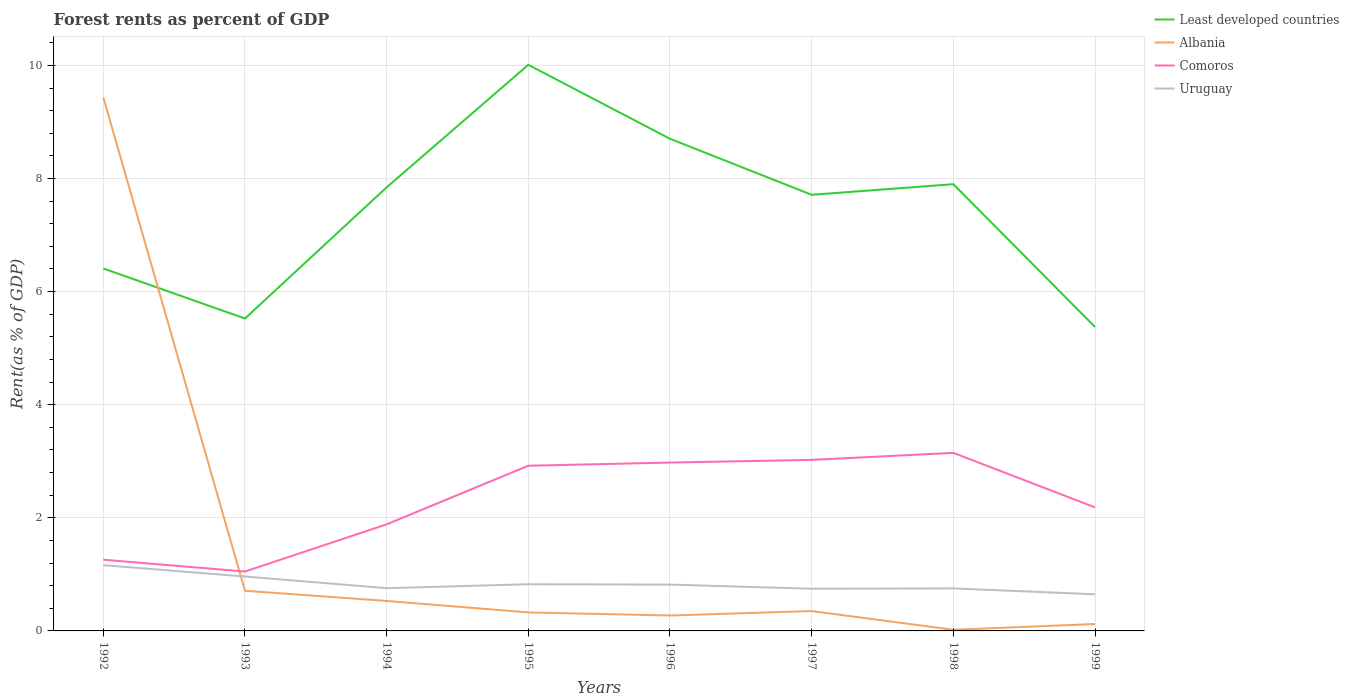How many different coloured lines are there?
Your answer should be compact. 4. Across all years, what is the maximum forest rent in Albania?
Your answer should be compact. 0.02. What is the total forest rent in Comoros in the graph?
Provide a succinct answer. -1.72. What is the difference between the highest and the second highest forest rent in Albania?
Provide a short and direct response. 9.42. How many lines are there?
Offer a terse response. 4. What is the difference between two consecutive major ticks on the Y-axis?
Your answer should be very brief. 2. How are the legend labels stacked?
Give a very brief answer. Vertical. What is the title of the graph?
Your response must be concise. Forest rents as percent of GDP. Does "West Bank and Gaza" appear as one of the legend labels in the graph?
Your response must be concise. No. What is the label or title of the Y-axis?
Make the answer very short. Rent(as % of GDP). What is the Rent(as % of GDP) in Least developed countries in 1992?
Your answer should be very brief. 6.41. What is the Rent(as % of GDP) in Albania in 1992?
Your answer should be compact. 9.44. What is the Rent(as % of GDP) in Comoros in 1992?
Keep it short and to the point. 1.26. What is the Rent(as % of GDP) in Uruguay in 1992?
Provide a short and direct response. 1.16. What is the Rent(as % of GDP) in Least developed countries in 1993?
Offer a terse response. 5.52. What is the Rent(as % of GDP) of Albania in 1993?
Ensure brevity in your answer.  0.71. What is the Rent(as % of GDP) in Comoros in 1993?
Keep it short and to the point. 1.05. What is the Rent(as % of GDP) of Uruguay in 1993?
Keep it short and to the point. 0.96. What is the Rent(as % of GDP) of Least developed countries in 1994?
Provide a succinct answer. 7.84. What is the Rent(as % of GDP) of Albania in 1994?
Keep it short and to the point. 0.53. What is the Rent(as % of GDP) of Comoros in 1994?
Offer a terse response. 1.88. What is the Rent(as % of GDP) of Uruguay in 1994?
Ensure brevity in your answer.  0.76. What is the Rent(as % of GDP) in Least developed countries in 1995?
Keep it short and to the point. 10.01. What is the Rent(as % of GDP) in Albania in 1995?
Give a very brief answer. 0.33. What is the Rent(as % of GDP) of Comoros in 1995?
Your answer should be very brief. 2.92. What is the Rent(as % of GDP) in Uruguay in 1995?
Provide a short and direct response. 0.83. What is the Rent(as % of GDP) of Least developed countries in 1996?
Offer a very short reply. 8.7. What is the Rent(as % of GDP) of Albania in 1996?
Your response must be concise. 0.27. What is the Rent(as % of GDP) of Comoros in 1996?
Your answer should be compact. 2.98. What is the Rent(as % of GDP) in Uruguay in 1996?
Offer a terse response. 0.82. What is the Rent(as % of GDP) of Least developed countries in 1997?
Your response must be concise. 7.71. What is the Rent(as % of GDP) in Albania in 1997?
Your answer should be compact. 0.35. What is the Rent(as % of GDP) in Comoros in 1997?
Ensure brevity in your answer.  3.02. What is the Rent(as % of GDP) in Uruguay in 1997?
Give a very brief answer. 0.75. What is the Rent(as % of GDP) of Least developed countries in 1998?
Offer a terse response. 7.9. What is the Rent(as % of GDP) of Albania in 1998?
Provide a short and direct response. 0.02. What is the Rent(as % of GDP) in Comoros in 1998?
Your answer should be very brief. 3.15. What is the Rent(as % of GDP) in Uruguay in 1998?
Your response must be concise. 0.75. What is the Rent(as % of GDP) of Least developed countries in 1999?
Your response must be concise. 5.38. What is the Rent(as % of GDP) in Albania in 1999?
Your answer should be compact. 0.12. What is the Rent(as % of GDP) in Comoros in 1999?
Offer a terse response. 2.18. What is the Rent(as % of GDP) in Uruguay in 1999?
Ensure brevity in your answer.  0.65. Across all years, what is the maximum Rent(as % of GDP) of Least developed countries?
Give a very brief answer. 10.01. Across all years, what is the maximum Rent(as % of GDP) in Albania?
Give a very brief answer. 9.44. Across all years, what is the maximum Rent(as % of GDP) in Comoros?
Your response must be concise. 3.15. Across all years, what is the maximum Rent(as % of GDP) in Uruguay?
Offer a very short reply. 1.16. Across all years, what is the minimum Rent(as % of GDP) of Least developed countries?
Your answer should be very brief. 5.38. Across all years, what is the minimum Rent(as % of GDP) of Albania?
Give a very brief answer. 0.02. Across all years, what is the minimum Rent(as % of GDP) in Comoros?
Your answer should be compact. 1.05. Across all years, what is the minimum Rent(as % of GDP) in Uruguay?
Provide a succinct answer. 0.65. What is the total Rent(as % of GDP) of Least developed countries in the graph?
Ensure brevity in your answer.  59.48. What is the total Rent(as % of GDP) in Albania in the graph?
Give a very brief answer. 11.77. What is the total Rent(as % of GDP) of Comoros in the graph?
Give a very brief answer. 18.45. What is the total Rent(as % of GDP) in Uruguay in the graph?
Your answer should be compact. 6.67. What is the difference between the Rent(as % of GDP) of Least developed countries in 1992 and that in 1993?
Ensure brevity in your answer.  0.89. What is the difference between the Rent(as % of GDP) in Albania in 1992 and that in 1993?
Provide a short and direct response. 8.73. What is the difference between the Rent(as % of GDP) of Comoros in 1992 and that in 1993?
Offer a very short reply. 0.21. What is the difference between the Rent(as % of GDP) of Uruguay in 1992 and that in 1993?
Offer a very short reply. 0.2. What is the difference between the Rent(as % of GDP) in Least developed countries in 1992 and that in 1994?
Your answer should be very brief. -1.43. What is the difference between the Rent(as % of GDP) of Albania in 1992 and that in 1994?
Offer a terse response. 8.91. What is the difference between the Rent(as % of GDP) in Comoros in 1992 and that in 1994?
Your answer should be compact. -0.62. What is the difference between the Rent(as % of GDP) of Uruguay in 1992 and that in 1994?
Ensure brevity in your answer.  0.41. What is the difference between the Rent(as % of GDP) of Least developed countries in 1992 and that in 1995?
Offer a terse response. -3.6. What is the difference between the Rent(as % of GDP) of Albania in 1992 and that in 1995?
Give a very brief answer. 9.11. What is the difference between the Rent(as % of GDP) of Comoros in 1992 and that in 1995?
Give a very brief answer. -1.66. What is the difference between the Rent(as % of GDP) of Uruguay in 1992 and that in 1995?
Provide a short and direct response. 0.34. What is the difference between the Rent(as % of GDP) in Least developed countries in 1992 and that in 1996?
Keep it short and to the point. -2.29. What is the difference between the Rent(as % of GDP) of Albania in 1992 and that in 1996?
Provide a short and direct response. 9.16. What is the difference between the Rent(as % of GDP) in Comoros in 1992 and that in 1996?
Offer a very short reply. -1.72. What is the difference between the Rent(as % of GDP) in Uruguay in 1992 and that in 1996?
Ensure brevity in your answer.  0.34. What is the difference between the Rent(as % of GDP) of Least developed countries in 1992 and that in 1997?
Provide a succinct answer. -1.3. What is the difference between the Rent(as % of GDP) in Albania in 1992 and that in 1997?
Make the answer very short. 9.09. What is the difference between the Rent(as % of GDP) of Comoros in 1992 and that in 1997?
Provide a succinct answer. -1.76. What is the difference between the Rent(as % of GDP) in Uruguay in 1992 and that in 1997?
Ensure brevity in your answer.  0.42. What is the difference between the Rent(as % of GDP) of Least developed countries in 1992 and that in 1998?
Your answer should be compact. -1.49. What is the difference between the Rent(as % of GDP) in Albania in 1992 and that in 1998?
Your response must be concise. 9.42. What is the difference between the Rent(as % of GDP) of Comoros in 1992 and that in 1998?
Your answer should be very brief. -1.89. What is the difference between the Rent(as % of GDP) in Uruguay in 1992 and that in 1998?
Ensure brevity in your answer.  0.41. What is the difference between the Rent(as % of GDP) of Least developed countries in 1992 and that in 1999?
Keep it short and to the point. 1.03. What is the difference between the Rent(as % of GDP) in Albania in 1992 and that in 1999?
Your answer should be compact. 9.31. What is the difference between the Rent(as % of GDP) of Comoros in 1992 and that in 1999?
Keep it short and to the point. -0.93. What is the difference between the Rent(as % of GDP) of Uruguay in 1992 and that in 1999?
Ensure brevity in your answer.  0.51. What is the difference between the Rent(as % of GDP) in Least developed countries in 1993 and that in 1994?
Provide a succinct answer. -2.32. What is the difference between the Rent(as % of GDP) of Albania in 1993 and that in 1994?
Provide a succinct answer. 0.18. What is the difference between the Rent(as % of GDP) of Comoros in 1993 and that in 1994?
Your answer should be very brief. -0.83. What is the difference between the Rent(as % of GDP) in Uruguay in 1993 and that in 1994?
Offer a very short reply. 0.21. What is the difference between the Rent(as % of GDP) in Least developed countries in 1993 and that in 1995?
Provide a short and direct response. -4.49. What is the difference between the Rent(as % of GDP) in Albania in 1993 and that in 1995?
Provide a succinct answer. 0.38. What is the difference between the Rent(as % of GDP) of Comoros in 1993 and that in 1995?
Your response must be concise. -1.87. What is the difference between the Rent(as % of GDP) in Uruguay in 1993 and that in 1995?
Provide a succinct answer. 0.14. What is the difference between the Rent(as % of GDP) of Least developed countries in 1993 and that in 1996?
Give a very brief answer. -3.18. What is the difference between the Rent(as % of GDP) in Albania in 1993 and that in 1996?
Offer a very short reply. 0.44. What is the difference between the Rent(as % of GDP) of Comoros in 1993 and that in 1996?
Ensure brevity in your answer.  -1.93. What is the difference between the Rent(as % of GDP) of Uruguay in 1993 and that in 1996?
Your answer should be compact. 0.14. What is the difference between the Rent(as % of GDP) of Least developed countries in 1993 and that in 1997?
Your answer should be very brief. -2.19. What is the difference between the Rent(as % of GDP) in Albania in 1993 and that in 1997?
Keep it short and to the point. 0.36. What is the difference between the Rent(as % of GDP) of Comoros in 1993 and that in 1997?
Provide a short and direct response. -1.97. What is the difference between the Rent(as % of GDP) in Uruguay in 1993 and that in 1997?
Keep it short and to the point. 0.22. What is the difference between the Rent(as % of GDP) in Least developed countries in 1993 and that in 1998?
Keep it short and to the point. -2.38. What is the difference between the Rent(as % of GDP) in Albania in 1993 and that in 1998?
Your response must be concise. 0.69. What is the difference between the Rent(as % of GDP) of Comoros in 1993 and that in 1998?
Offer a terse response. -2.1. What is the difference between the Rent(as % of GDP) in Uruguay in 1993 and that in 1998?
Make the answer very short. 0.21. What is the difference between the Rent(as % of GDP) in Least developed countries in 1993 and that in 1999?
Provide a short and direct response. 0.15. What is the difference between the Rent(as % of GDP) of Albania in 1993 and that in 1999?
Provide a succinct answer. 0.59. What is the difference between the Rent(as % of GDP) in Comoros in 1993 and that in 1999?
Ensure brevity in your answer.  -1.13. What is the difference between the Rent(as % of GDP) in Uruguay in 1993 and that in 1999?
Your answer should be very brief. 0.31. What is the difference between the Rent(as % of GDP) in Least developed countries in 1994 and that in 1995?
Offer a very short reply. -2.17. What is the difference between the Rent(as % of GDP) in Albania in 1994 and that in 1995?
Your answer should be very brief. 0.2. What is the difference between the Rent(as % of GDP) in Comoros in 1994 and that in 1995?
Your response must be concise. -1.04. What is the difference between the Rent(as % of GDP) in Uruguay in 1994 and that in 1995?
Keep it short and to the point. -0.07. What is the difference between the Rent(as % of GDP) of Least developed countries in 1994 and that in 1996?
Your answer should be very brief. -0.86. What is the difference between the Rent(as % of GDP) of Albania in 1994 and that in 1996?
Your answer should be very brief. 0.26. What is the difference between the Rent(as % of GDP) of Comoros in 1994 and that in 1996?
Keep it short and to the point. -1.09. What is the difference between the Rent(as % of GDP) in Uruguay in 1994 and that in 1996?
Provide a short and direct response. -0.06. What is the difference between the Rent(as % of GDP) in Least developed countries in 1994 and that in 1997?
Provide a short and direct response. 0.13. What is the difference between the Rent(as % of GDP) of Albania in 1994 and that in 1997?
Your response must be concise. 0.18. What is the difference between the Rent(as % of GDP) in Comoros in 1994 and that in 1997?
Offer a very short reply. -1.14. What is the difference between the Rent(as % of GDP) in Uruguay in 1994 and that in 1997?
Your response must be concise. 0.01. What is the difference between the Rent(as % of GDP) of Least developed countries in 1994 and that in 1998?
Offer a terse response. -0.06. What is the difference between the Rent(as % of GDP) of Albania in 1994 and that in 1998?
Your answer should be very brief. 0.51. What is the difference between the Rent(as % of GDP) of Comoros in 1994 and that in 1998?
Your response must be concise. -1.26. What is the difference between the Rent(as % of GDP) of Uruguay in 1994 and that in 1998?
Give a very brief answer. 0. What is the difference between the Rent(as % of GDP) of Least developed countries in 1994 and that in 1999?
Your answer should be very brief. 2.47. What is the difference between the Rent(as % of GDP) in Albania in 1994 and that in 1999?
Offer a very short reply. 0.41. What is the difference between the Rent(as % of GDP) in Comoros in 1994 and that in 1999?
Your answer should be compact. -0.3. What is the difference between the Rent(as % of GDP) of Uruguay in 1994 and that in 1999?
Keep it short and to the point. 0.11. What is the difference between the Rent(as % of GDP) of Least developed countries in 1995 and that in 1996?
Offer a very short reply. 1.31. What is the difference between the Rent(as % of GDP) of Albania in 1995 and that in 1996?
Make the answer very short. 0.05. What is the difference between the Rent(as % of GDP) in Comoros in 1995 and that in 1996?
Your response must be concise. -0.06. What is the difference between the Rent(as % of GDP) of Uruguay in 1995 and that in 1996?
Make the answer very short. 0.01. What is the difference between the Rent(as % of GDP) in Least developed countries in 1995 and that in 1997?
Give a very brief answer. 2.3. What is the difference between the Rent(as % of GDP) in Albania in 1995 and that in 1997?
Your response must be concise. -0.02. What is the difference between the Rent(as % of GDP) in Comoros in 1995 and that in 1997?
Offer a terse response. -0.1. What is the difference between the Rent(as % of GDP) of Uruguay in 1995 and that in 1997?
Ensure brevity in your answer.  0.08. What is the difference between the Rent(as % of GDP) in Least developed countries in 1995 and that in 1998?
Offer a terse response. 2.11. What is the difference between the Rent(as % of GDP) in Albania in 1995 and that in 1998?
Your answer should be very brief. 0.31. What is the difference between the Rent(as % of GDP) of Comoros in 1995 and that in 1998?
Ensure brevity in your answer.  -0.23. What is the difference between the Rent(as % of GDP) of Uruguay in 1995 and that in 1998?
Provide a succinct answer. 0.07. What is the difference between the Rent(as % of GDP) in Least developed countries in 1995 and that in 1999?
Give a very brief answer. 4.63. What is the difference between the Rent(as % of GDP) in Albania in 1995 and that in 1999?
Keep it short and to the point. 0.2. What is the difference between the Rent(as % of GDP) in Comoros in 1995 and that in 1999?
Your response must be concise. 0.74. What is the difference between the Rent(as % of GDP) of Uruguay in 1995 and that in 1999?
Provide a short and direct response. 0.18. What is the difference between the Rent(as % of GDP) in Least developed countries in 1996 and that in 1997?
Your response must be concise. 0.99. What is the difference between the Rent(as % of GDP) of Albania in 1996 and that in 1997?
Provide a succinct answer. -0.08. What is the difference between the Rent(as % of GDP) of Comoros in 1996 and that in 1997?
Make the answer very short. -0.05. What is the difference between the Rent(as % of GDP) of Uruguay in 1996 and that in 1997?
Provide a short and direct response. 0.07. What is the difference between the Rent(as % of GDP) in Least developed countries in 1996 and that in 1998?
Provide a short and direct response. 0.8. What is the difference between the Rent(as % of GDP) in Albania in 1996 and that in 1998?
Ensure brevity in your answer.  0.25. What is the difference between the Rent(as % of GDP) in Comoros in 1996 and that in 1998?
Your answer should be compact. -0.17. What is the difference between the Rent(as % of GDP) of Uruguay in 1996 and that in 1998?
Ensure brevity in your answer.  0.07. What is the difference between the Rent(as % of GDP) in Least developed countries in 1996 and that in 1999?
Provide a short and direct response. 3.33. What is the difference between the Rent(as % of GDP) of Albania in 1996 and that in 1999?
Offer a terse response. 0.15. What is the difference between the Rent(as % of GDP) in Comoros in 1996 and that in 1999?
Give a very brief answer. 0.79. What is the difference between the Rent(as % of GDP) of Uruguay in 1996 and that in 1999?
Your answer should be very brief. 0.17. What is the difference between the Rent(as % of GDP) in Least developed countries in 1997 and that in 1998?
Keep it short and to the point. -0.19. What is the difference between the Rent(as % of GDP) in Albania in 1997 and that in 1998?
Make the answer very short. 0.33. What is the difference between the Rent(as % of GDP) in Comoros in 1997 and that in 1998?
Make the answer very short. -0.12. What is the difference between the Rent(as % of GDP) of Uruguay in 1997 and that in 1998?
Ensure brevity in your answer.  -0.01. What is the difference between the Rent(as % of GDP) of Least developed countries in 1997 and that in 1999?
Offer a very short reply. 2.34. What is the difference between the Rent(as % of GDP) in Albania in 1997 and that in 1999?
Keep it short and to the point. 0.23. What is the difference between the Rent(as % of GDP) of Comoros in 1997 and that in 1999?
Offer a terse response. 0.84. What is the difference between the Rent(as % of GDP) of Uruguay in 1997 and that in 1999?
Make the answer very short. 0.1. What is the difference between the Rent(as % of GDP) in Least developed countries in 1998 and that in 1999?
Your answer should be very brief. 2.52. What is the difference between the Rent(as % of GDP) in Albania in 1998 and that in 1999?
Offer a very short reply. -0.1. What is the difference between the Rent(as % of GDP) of Comoros in 1998 and that in 1999?
Make the answer very short. 0.96. What is the difference between the Rent(as % of GDP) of Uruguay in 1998 and that in 1999?
Make the answer very short. 0.1. What is the difference between the Rent(as % of GDP) in Least developed countries in 1992 and the Rent(as % of GDP) in Albania in 1993?
Ensure brevity in your answer.  5.7. What is the difference between the Rent(as % of GDP) in Least developed countries in 1992 and the Rent(as % of GDP) in Comoros in 1993?
Make the answer very short. 5.36. What is the difference between the Rent(as % of GDP) in Least developed countries in 1992 and the Rent(as % of GDP) in Uruguay in 1993?
Provide a succinct answer. 5.45. What is the difference between the Rent(as % of GDP) in Albania in 1992 and the Rent(as % of GDP) in Comoros in 1993?
Your answer should be very brief. 8.39. What is the difference between the Rent(as % of GDP) of Albania in 1992 and the Rent(as % of GDP) of Uruguay in 1993?
Offer a very short reply. 8.47. What is the difference between the Rent(as % of GDP) in Comoros in 1992 and the Rent(as % of GDP) in Uruguay in 1993?
Your response must be concise. 0.3. What is the difference between the Rent(as % of GDP) in Least developed countries in 1992 and the Rent(as % of GDP) in Albania in 1994?
Give a very brief answer. 5.88. What is the difference between the Rent(as % of GDP) in Least developed countries in 1992 and the Rent(as % of GDP) in Comoros in 1994?
Provide a short and direct response. 4.53. What is the difference between the Rent(as % of GDP) of Least developed countries in 1992 and the Rent(as % of GDP) of Uruguay in 1994?
Ensure brevity in your answer.  5.65. What is the difference between the Rent(as % of GDP) in Albania in 1992 and the Rent(as % of GDP) in Comoros in 1994?
Give a very brief answer. 7.55. What is the difference between the Rent(as % of GDP) in Albania in 1992 and the Rent(as % of GDP) in Uruguay in 1994?
Your answer should be compact. 8.68. What is the difference between the Rent(as % of GDP) in Comoros in 1992 and the Rent(as % of GDP) in Uruguay in 1994?
Ensure brevity in your answer.  0.5. What is the difference between the Rent(as % of GDP) in Least developed countries in 1992 and the Rent(as % of GDP) in Albania in 1995?
Your answer should be compact. 6.08. What is the difference between the Rent(as % of GDP) in Least developed countries in 1992 and the Rent(as % of GDP) in Comoros in 1995?
Give a very brief answer. 3.49. What is the difference between the Rent(as % of GDP) in Least developed countries in 1992 and the Rent(as % of GDP) in Uruguay in 1995?
Keep it short and to the point. 5.58. What is the difference between the Rent(as % of GDP) of Albania in 1992 and the Rent(as % of GDP) of Comoros in 1995?
Offer a very short reply. 6.52. What is the difference between the Rent(as % of GDP) of Albania in 1992 and the Rent(as % of GDP) of Uruguay in 1995?
Give a very brief answer. 8.61. What is the difference between the Rent(as % of GDP) in Comoros in 1992 and the Rent(as % of GDP) in Uruguay in 1995?
Provide a short and direct response. 0.43. What is the difference between the Rent(as % of GDP) of Least developed countries in 1992 and the Rent(as % of GDP) of Albania in 1996?
Provide a succinct answer. 6.14. What is the difference between the Rent(as % of GDP) in Least developed countries in 1992 and the Rent(as % of GDP) in Comoros in 1996?
Give a very brief answer. 3.43. What is the difference between the Rent(as % of GDP) of Least developed countries in 1992 and the Rent(as % of GDP) of Uruguay in 1996?
Your response must be concise. 5.59. What is the difference between the Rent(as % of GDP) of Albania in 1992 and the Rent(as % of GDP) of Comoros in 1996?
Your response must be concise. 6.46. What is the difference between the Rent(as % of GDP) of Albania in 1992 and the Rent(as % of GDP) of Uruguay in 1996?
Your answer should be very brief. 8.62. What is the difference between the Rent(as % of GDP) of Comoros in 1992 and the Rent(as % of GDP) of Uruguay in 1996?
Give a very brief answer. 0.44. What is the difference between the Rent(as % of GDP) of Least developed countries in 1992 and the Rent(as % of GDP) of Albania in 1997?
Provide a succinct answer. 6.06. What is the difference between the Rent(as % of GDP) of Least developed countries in 1992 and the Rent(as % of GDP) of Comoros in 1997?
Keep it short and to the point. 3.39. What is the difference between the Rent(as % of GDP) in Least developed countries in 1992 and the Rent(as % of GDP) in Uruguay in 1997?
Make the answer very short. 5.66. What is the difference between the Rent(as % of GDP) in Albania in 1992 and the Rent(as % of GDP) in Comoros in 1997?
Your answer should be compact. 6.41. What is the difference between the Rent(as % of GDP) in Albania in 1992 and the Rent(as % of GDP) in Uruguay in 1997?
Provide a short and direct response. 8.69. What is the difference between the Rent(as % of GDP) in Comoros in 1992 and the Rent(as % of GDP) in Uruguay in 1997?
Your answer should be compact. 0.51. What is the difference between the Rent(as % of GDP) in Least developed countries in 1992 and the Rent(as % of GDP) in Albania in 1998?
Your response must be concise. 6.39. What is the difference between the Rent(as % of GDP) of Least developed countries in 1992 and the Rent(as % of GDP) of Comoros in 1998?
Make the answer very short. 3.26. What is the difference between the Rent(as % of GDP) in Least developed countries in 1992 and the Rent(as % of GDP) in Uruguay in 1998?
Provide a short and direct response. 5.66. What is the difference between the Rent(as % of GDP) in Albania in 1992 and the Rent(as % of GDP) in Comoros in 1998?
Offer a very short reply. 6.29. What is the difference between the Rent(as % of GDP) of Albania in 1992 and the Rent(as % of GDP) of Uruguay in 1998?
Provide a short and direct response. 8.68. What is the difference between the Rent(as % of GDP) of Comoros in 1992 and the Rent(as % of GDP) of Uruguay in 1998?
Provide a succinct answer. 0.51. What is the difference between the Rent(as % of GDP) in Least developed countries in 1992 and the Rent(as % of GDP) in Albania in 1999?
Keep it short and to the point. 6.29. What is the difference between the Rent(as % of GDP) in Least developed countries in 1992 and the Rent(as % of GDP) in Comoros in 1999?
Ensure brevity in your answer.  4.22. What is the difference between the Rent(as % of GDP) of Least developed countries in 1992 and the Rent(as % of GDP) of Uruguay in 1999?
Offer a terse response. 5.76. What is the difference between the Rent(as % of GDP) of Albania in 1992 and the Rent(as % of GDP) of Comoros in 1999?
Keep it short and to the point. 7.25. What is the difference between the Rent(as % of GDP) of Albania in 1992 and the Rent(as % of GDP) of Uruguay in 1999?
Ensure brevity in your answer.  8.79. What is the difference between the Rent(as % of GDP) in Comoros in 1992 and the Rent(as % of GDP) in Uruguay in 1999?
Ensure brevity in your answer.  0.61. What is the difference between the Rent(as % of GDP) of Least developed countries in 1993 and the Rent(as % of GDP) of Albania in 1994?
Provide a short and direct response. 4.99. What is the difference between the Rent(as % of GDP) in Least developed countries in 1993 and the Rent(as % of GDP) in Comoros in 1994?
Keep it short and to the point. 3.64. What is the difference between the Rent(as % of GDP) of Least developed countries in 1993 and the Rent(as % of GDP) of Uruguay in 1994?
Offer a very short reply. 4.77. What is the difference between the Rent(as % of GDP) of Albania in 1993 and the Rent(as % of GDP) of Comoros in 1994?
Give a very brief answer. -1.17. What is the difference between the Rent(as % of GDP) in Albania in 1993 and the Rent(as % of GDP) in Uruguay in 1994?
Provide a short and direct response. -0.05. What is the difference between the Rent(as % of GDP) of Comoros in 1993 and the Rent(as % of GDP) of Uruguay in 1994?
Offer a very short reply. 0.29. What is the difference between the Rent(as % of GDP) in Least developed countries in 1993 and the Rent(as % of GDP) in Albania in 1995?
Ensure brevity in your answer.  5.2. What is the difference between the Rent(as % of GDP) in Least developed countries in 1993 and the Rent(as % of GDP) in Comoros in 1995?
Provide a succinct answer. 2.6. What is the difference between the Rent(as % of GDP) of Least developed countries in 1993 and the Rent(as % of GDP) of Uruguay in 1995?
Your answer should be compact. 4.7. What is the difference between the Rent(as % of GDP) of Albania in 1993 and the Rent(as % of GDP) of Comoros in 1995?
Provide a succinct answer. -2.21. What is the difference between the Rent(as % of GDP) of Albania in 1993 and the Rent(as % of GDP) of Uruguay in 1995?
Provide a succinct answer. -0.12. What is the difference between the Rent(as % of GDP) of Comoros in 1993 and the Rent(as % of GDP) of Uruguay in 1995?
Provide a short and direct response. 0.23. What is the difference between the Rent(as % of GDP) in Least developed countries in 1993 and the Rent(as % of GDP) in Albania in 1996?
Ensure brevity in your answer.  5.25. What is the difference between the Rent(as % of GDP) in Least developed countries in 1993 and the Rent(as % of GDP) in Comoros in 1996?
Provide a short and direct response. 2.55. What is the difference between the Rent(as % of GDP) in Least developed countries in 1993 and the Rent(as % of GDP) in Uruguay in 1996?
Keep it short and to the point. 4.7. What is the difference between the Rent(as % of GDP) in Albania in 1993 and the Rent(as % of GDP) in Comoros in 1996?
Provide a short and direct response. -2.27. What is the difference between the Rent(as % of GDP) of Albania in 1993 and the Rent(as % of GDP) of Uruguay in 1996?
Ensure brevity in your answer.  -0.11. What is the difference between the Rent(as % of GDP) in Comoros in 1993 and the Rent(as % of GDP) in Uruguay in 1996?
Offer a very short reply. 0.23. What is the difference between the Rent(as % of GDP) of Least developed countries in 1993 and the Rent(as % of GDP) of Albania in 1997?
Ensure brevity in your answer.  5.17. What is the difference between the Rent(as % of GDP) in Least developed countries in 1993 and the Rent(as % of GDP) in Comoros in 1997?
Provide a succinct answer. 2.5. What is the difference between the Rent(as % of GDP) of Least developed countries in 1993 and the Rent(as % of GDP) of Uruguay in 1997?
Your response must be concise. 4.78. What is the difference between the Rent(as % of GDP) of Albania in 1993 and the Rent(as % of GDP) of Comoros in 1997?
Give a very brief answer. -2.31. What is the difference between the Rent(as % of GDP) in Albania in 1993 and the Rent(as % of GDP) in Uruguay in 1997?
Your answer should be very brief. -0.04. What is the difference between the Rent(as % of GDP) of Comoros in 1993 and the Rent(as % of GDP) of Uruguay in 1997?
Provide a succinct answer. 0.3. What is the difference between the Rent(as % of GDP) in Least developed countries in 1993 and the Rent(as % of GDP) in Albania in 1998?
Offer a very short reply. 5.5. What is the difference between the Rent(as % of GDP) in Least developed countries in 1993 and the Rent(as % of GDP) in Comoros in 1998?
Offer a terse response. 2.38. What is the difference between the Rent(as % of GDP) of Least developed countries in 1993 and the Rent(as % of GDP) of Uruguay in 1998?
Provide a short and direct response. 4.77. What is the difference between the Rent(as % of GDP) of Albania in 1993 and the Rent(as % of GDP) of Comoros in 1998?
Your answer should be very brief. -2.44. What is the difference between the Rent(as % of GDP) in Albania in 1993 and the Rent(as % of GDP) in Uruguay in 1998?
Offer a terse response. -0.04. What is the difference between the Rent(as % of GDP) in Comoros in 1993 and the Rent(as % of GDP) in Uruguay in 1998?
Provide a succinct answer. 0.3. What is the difference between the Rent(as % of GDP) of Least developed countries in 1993 and the Rent(as % of GDP) of Albania in 1999?
Your answer should be very brief. 5.4. What is the difference between the Rent(as % of GDP) in Least developed countries in 1993 and the Rent(as % of GDP) in Comoros in 1999?
Keep it short and to the point. 3.34. What is the difference between the Rent(as % of GDP) in Least developed countries in 1993 and the Rent(as % of GDP) in Uruguay in 1999?
Provide a succinct answer. 4.88. What is the difference between the Rent(as % of GDP) in Albania in 1993 and the Rent(as % of GDP) in Comoros in 1999?
Make the answer very short. -1.47. What is the difference between the Rent(as % of GDP) of Albania in 1993 and the Rent(as % of GDP) of Uruguay in 1999?
Provide a succinct answer. 0.06. What is the difference between the Rent(as % of GDP) in Comoros in 1993 and the Rent(as % of GDP) in Uruguay in 1999?
Your answer should be very brief. 0.4. What is the difference between the Rent(as % of GDP) of Least developed countries in 1994 and the Rent(as % of GDP) of Albania in 1995?
Offer a terse response. 7.52. What is the difference between the Rent(as % of GDP) in Least developed countries in 1994 and the Rent(as % of GDP) in Comoros in 1995?
Your response must be concise. 4.92. What is the difference between the Rent(as % of GDP) in Least developed countries in 1994 and the Rent(as % of GDP) in Uruguay in 1995?
Your answer should be very brief. 7.02. What is the difference between the Rent(as % of GDP) of Albania in 1994 and the Rent(as % of GDP) of Comoros in 1995?
Provide a succinct answer. -2.39. What is the difference between the Rent(as % of GDP) of Albania in 1994 and the Rent(as % of GDP) of Uruguay in 1995?
Make the answer very short. -0.3. What is the difference between the Rent(as % of GDP) of Comoros in 1994 and the Rent(as % of GDP) of Uruguay in 1995?
Provide a short and direct response. 1.06. What is the difference between the Rent(as % of GDP) of Least developed countries in 1994 and the Rent(as % of GDP) of Albania in 1996?
Ensure brevity in your answer.  7.57. What is the difference between the Rent(as % of GDP) in Least developed countries in 1994 and the Rent(as % of GDP) in Comoros in 1996?
Your answer should be compact. 4.87. What is the difference between the Rent(as % of GDP) in Least developed countries in 1994 and the Rent(as % of GDP) in Uruguay in 1996?
Provide a short and direct response. 7.02. What is the difference between the Rent(as % of GDP) in Albania in 1994 and the Rent(as % of GDP) in Comoros in 1996?
Provide a succinct answer. -2.45. What is the difference between the Rent(as % of GDP) of Albania in 1994 and the Rent(as % of GDP) of Uruguay in 1996?
Give a very brief answer. -0.29. What is the difference between the Rent(as % of GDP) of Comoros in 1994 and the Rent(as % of GDP) of Uruguay in 1996?
Provide a short and direct response. 1.06. What is the difference between the Rent(as % of GDP) of Least developed countries in 1994 and the Rent(as % of GDP) of Albania in 1997?
Ensure brevity in your answer.  7.49. What is the difference between the Rent(as % of GDP) of Least developed countries in 1994 and the Rent(as % of GDP) of Comoros in 1997?
Make the answer very short. 4.82. What is the difference between the Rent(as % of GDP) of Least developed countries in 1994 and the Rent(as % of GDP) of Uruguay in 1997?
Your answer should be compact. 7.1. What is the difference between the Rent(as % of GDP) of Albania in 1994 and the Rent(as % of GDP) of Comoros in 1997?
Provide a succinct answer. -2.49. What is the difference between the Rent(as % of GDP) in Albania in 1994 and the Rent(as % of GDP) in Uruguay in 1997?
Ensure brevity in your answer.  -0.22. What is the difference between the Rent(as % of GDP) in Comoros in 1994 and the Rent(as % of GDP) in Uruguay in 1997?
Your response must be concise. 1.14. What is the difference between the Rent(as % of GDP) in Least developed countries in 1994 and the Rent(as % of GDP) in Albania in 1998?
Give a very brief answer. 7.82. What is the difference between the Rent(as % of GDP) of Least developed countries in 1994 and the Rent(as % of GDP) of Comoros in 1998?
Your answer should be compact. 4.7. What is the difference between the Rent(as % of GDP) in Least developed countries in 1994 and the Rent(as % of GDP) in Uruguay in 1998?
Your answer should be compact. 7.09. What is the difference between the Rent(as % of GDP) in Albania in 1994 and the Rent(as % of GDP) in Comoros in 1998?
Your answer should be compact. -2.62. What is the difference between the Rent(as % of GDP) of Albania in 1994 and the Rent(as % of GDP) of Uruguay in 1998?
Give a very brief answer. -0.22. What is the difference between the Rent(as % of GDP) of Comoros in 1994 and the Rent(as % of GDP) of Uruguay in 1998?
Provide a succinct answer. 1.13. What is the difference between the Rent(as % of GDP) in Least developed countries in 1994 and the Rent(as % of GDP) in Albania in 1999?
Keep it short and to the point. 7.72. What is the difference between the Rent(as % of GDP) of Least developed countries in 1994 and the Rent(as % of GDP) of Comoros in 1999?
Your answer should be compact. 5.66. What is the difference between the Rent(as % of GDP) in Least developed countries in 1994 and the Rent(as % of GDP) in Uruguay in 1999?
Provide a succinct answer. 7.2. What is the difference between the Rent(as % of GDP) in Albania in 1994 and the Rent(as % of GDP) in Comoros in 1999?
Your answer should be very brief. -1.65. What is the difference between the Rent(as % of GDP) of Albania in 1994 and the Rent(as % of GDP) of Uruguay in 1999?
Make the answer very short. -0.12. What is the difference between the Rent(as % of GDP) in Comoros in 1994 and the Rent(as % of GDP) in Uruguay in 1999?
Give a very brief answer. 1.24. What is the difference between the Rent(as % of GDP) in Least developed countries in 1995 and the Rent(as % of GDP) in Albania in 1996?
Your answer should be very brief. 9.74. What is the difference between the Rent(as % of GDP) in Least developed countries in 1995 and the Rent(as % of GDP) in Comoros in 1996?
Your answer should be very brief. 7.03. What is the difference between the Rent(as % of GDP) in Least developed countries in 1995 and the Rent(as % of GDP) in Uruguay in 1996?
Your answer should be very brief. 9.19. What is the difference between the Rent(as % of GDP) in Albania in 1995 and the Rent(as % of GDP) in Comoros in 1996?
Your response must be concise. -2.65. What is the difference between the Rent(as % of GDP) in Albania in 1995 and the Rent(as % of GDP) in Uruguay in 1996?
Keep it short and to the point. -0.49. What is the difference between the Rent(as % of GDP) in Comoros in 1995 and the Rent(as % of GDP) in Uruguay in 1996?
Give a very brief answer. 2.1. What is the difference between the Rent(as % of GDP) in Least developed countries in 1995 and the Rent(as % of GDP) in Albania in 1997?
Provide a succinct answer. 9.66. What is the difference between the Rent(as % of GDP) of Least developed countries in 1995 and the Rent(as % of GDP) of Comoros in 1997?
Keep it short and to the point. 6.99. What is the difference between the Rent(as % of GDP) in Least developed countries in 1995 and the Rent(as % of GDP) in Uruguay in 1997?
Keep it short and to the point. 9.26. What is the difference between the Rent(as % of GDP) in Albania in 1995 and the Rent(as % of GDP) in Comoros in 1997?
Make the answer very short. -2.7. What is the difference between the Rent(as % of GDP) in Albania in 1995 and the Rent(as % of GDP) in Uruguay in 1997?
Your response must be concise. -0.42. What is the difference between the Rent(as % of GDP) of Comoros in 1995 and the Rent(as % of GDP) of Uruguay in 1997?
Offer a very short reply. 2.18. What is the difference between the Rent(as % of GDP) in Least developed countries in 1995 and the Rent(as % of GDP) in Albania in 1998?
Provide a short and direct response. 9.99. What is the difference between the Rent(as % of GDP) in Least developed countries in 1995 and the Rent(as % of GDP) in Comoros in 1998?
Provide a short and direct response. 6.86. What is the difference between the Rent(as % of GDP) of Least developed countries in 1995 and the Rent(as % of GDP) of Uruguay in 1998?
Your answer should be very brief. 9.26. What is the difference between the Rent(as % of GDP) of Albania in 1995 and the Rent(as % of GDP) of Comoros in 1998?
Offer a terse response. -2.82. What is the difference between the Rent(as % of GDP) in Albania in 1995 and the Rent(as % of GDP) in Uruguay in 1998?
Your answer should be compact. -0.42. What is the difference between the Rent(as % of GDP) in Comoros in 1995 and the Rent(as % of GDP) in Uruguay in 1998?
Offer a terse response. 2.17. What is the difference between the Rent(as % of GDP) in Least developed countries in 1995 and the Rent(as % of GDP) in Albania in 1999?
Your response must be concise. 9.89. What is the difference between the Rent(as % of GDP) of Least developed countries in 1995 and the Rent(as % of GDP) of Comoros in 1999?
Make the answer very short. 7.83. What is the difference between the Rent(as % of GDP) of Least developed countries in 1995 and the Rent(as % of GDP) of Uruguay in 1999?
Keep it short and to the point. 9.36. What is the difference between the Rent(as % of GDP) of Albania in 1995 and the Rent(as % of GDP) of Comoros in 1999?
Provide a short and direct response. -1.86. What is the difference between the Rent(as % of GDP) of Albania in 1995 and the Rent(as % of GDP) of Uruguay in 1999?
Offer a very short reply. -0.32. What is the difference between the Rent(as % of GDP) of Comoros in 1995 and the Rent(as % of GDP) of Uruguay in 1999?
Make the answer very short. 2.27. What is the difference between the Rent(as % of GDP) in Least developed countries in 1996 and the Rent(as % of GDP) in Albania in 1997?
Your response must be concise. 8.35. What is the difference between the Rent(as % of GDP) in Least developed countries in 1996 and the Rent(as % of GDP) in Comoros in 1997?
Give a very brief answer. 5.68. What is the difference between the Rent(as % of GDP) in Least developed countries in 1996 and the Rent(as % of GDP) in Uruguay in 1997?
Ensure brevity in your answer.  7.96. What is the difference between the Rent(as % of GDP) of Albania in 1996 and the Rent(as % of GDP) of Comoros in 1997?
Ensure brevity in your answer.  -2.75. What is the difference between the Rent(as % of GDP) in Albania in 1996 and the Rent(as % of GDP) in Uruguay in 1997?
Provide a short and direct response. -0.47. What is the difference between the Rent(as % of GDP) in Comoros in 1996 and the Rent(as % of GDP) in Uruguay in 1997?
Your response must be concise. 2.23. What is the difference between the Rent(as % of GDP) of Least developed countries in 1996 and the Rent(as % of GDP) of Albania in 1998?
Provide a short and direct response. 8.68. What is the difference between the Rent(as % of GDP) of Least developed countries in 1996 and the Rent(as % of GDP) of Comoros in 1998?
Provide a short and direct response. 5.55. What is the difference between the Rent(as % of GDP) in Least developed countries in 1996 and the Rent(as % of GDP) in Uruguay in 1998?
Give a very brief answer. 7.95. What is the difference between the Rent(as % of GDP) in Albania in 1996 and the Rent(as % of GDP) in Comoros in 1998?
Your answer should be very brief. -2.88. What is the difference between the Rent(as % of GDP) of Albania in 1996 and the Rent(as % of GDP) of Uruguay in 1998?
Make the answer very short. -0.48. What is the difference between the Rent(as % of GDP) in Comoros in 1996 and the Rent(as % of GDP) in Uruguay in 1998?
Your answer should be very brief. 2.23. What is the difference between the Rent(as % of GDP) in Least developed countries in 1996 and the Rent(as % of GDP) in Albania in 1999?
Offer a terse response. 8.58. What is the difference between the Rent(as % of GDP) in Least developed countries in 1996 and the Rent(as % of GDP) in Comoros in 1999?
Offer a terse response. 6.52. What is the difference between the Rent(as % of GDP) in Least developed countries in 1996 and the Rent(as % of GDP) in Uruguay in 1999?
Offer a terse response. 8.05. What is the difference between the Rent(as % of GDP) in Albania in 1996 and the Rent(as % of GDP) in Comoros in 1999?
Provide a succinct answer. -1.91. What is the difference between the Rent(as % of GDP) of Albania in 1996 and the Rent(as % of GDP) of Uruguay in 1999?
Your response must be concise. -0.38. What is the difference between the Rent(as % of GDP) of Comoros in 1996 and the Rent(as % of GDP) of Uruguay in 1999?
Keep it short and to the point. 2.33. What is the difference between the Rent(as % of GDP) of Least developed countries in 1997 and the Rent(as % of GDP) of Albania in 1998?
Your answer should be compact. 7.69. What is the difference between the Rent(as % of GDP) of Least developed countries in 1997 and the Rent(as % of GDP) of Comoros in 1998?
Keep it short and to the point. 4.56. What is the difference between the Rent(as % of GDP) in Least developed countries in 1997 and the Rent(as % of GDP) in Uruguay in 1998?
Make the answer very short. 6.96. What is the difference between the Rent(as % of GDP) in Albania in 1997 and the Rent(as % of GDP) in Comoros in 1998?
Ensure brevity in your answer.  -2.8. What is the difference between the Rent(as % of GDP) of Albania in 1997 and the Rent(as % of GDP) of Uruguay in 1998?
Ensure brevity in your answer.  -0.4. What is the difference between the Rent(as % of GDP) in Comoros in 1997 and the Rent(as % of GDP) in Uruguay in 1998?
Provide a succinct answer. 2.27. What is the difference between the Rent(as % of GDP) in Least developed countries in 1997 and the Rent(as % of GDP) in Albania in 1999?
Give a very brief answer. 7.59. What is the difference between the Rent(as % of GDP) in Least developed countries in 1997 and the Rent(as % of GDP) in Comoros in 1999?
Your answer should be very brief. 5.53. What is the difference between the Rent(as % of GDP) in Least developed countries in 1997 and the Rent(as % of GDP) in Uruguay in 1999?
Give a very brief answer. 7.06. What is the difference between the Rent(as % of GDP) of Albania in 1997 and the Rent(as % of GDP) of Comoros in 1999?
Offer a very short reply. -1.83. What is the difference between the Rent(as % of GDP) of Albania in 1997 and the Rent(as % of GDP) of Uruguay in 1999?
Provide a succinct answer. -0.3. What is the difference between the Rent(as % of GDP) in Comoros in 1997 and the Rent(as % of GDP) in Uruguay in 1999?
Ensure brevity in your answer.  2.38. What is the difference between the Rent(as % of GDP) in Least developed countries in 1998 and the Rent(as % of GDP) in Albania in 1999?
Give a very brief answer. 7.78. What is the difference between the Rent(as % of GDP) of Least developed countries in 1998 and the Rent(as % of GDP) of Comoros in 1999?
Make the answer very short. 5.72. What is the difference between the Rent(as % of GDP) in Least developed countries in 1998 and the Rent(as % of GDP) in Uruguay in 1999?
Keep it short and to the point. 7.25. What is the difference between the Rent(as % of GDP) of Albania in 1998 and the Rent(as % of GDP) of Comoros in 1999?
Ensure brevity in your answer.  -2.16. What is the difference between the Rent(as % of GDP) of Albania in 1998 and the Rent(as % of GDP) of Uruguay in 1999?
Keep it short and to the point. -0.63. What is the difference between the Rent(as % of GDP) in Comoros in 1998 and the Rent(as % of GDP) in Uruguay in 1999?
Keep it short and to the point. 2.5. What is the average Rent(as % of GDP) in Least developed countries per year?
Provide a succinct answer. 7.43. What is the average Rent(as % of GDP) in Albania per year?
Make the answer very short. 1.47. What is the average Rent(as % of GDP) of Comoros per year?
Your answer should be very brief. 2.31. What is the average Rent(as % of GDP) of Uruguay per year?
Offer a very short reply. 0.83. In the year 1992, what is the difference between the Rent(as % of GDP) in Least developed countries and Rent(as % of GDP) in Albania?
Keep it short and to the point. -3.03. In the year 1992, what is the difference between the Rent(as % of GDP) of Least developed countries and Rent(as % of GDP) of Comoros?
Make the answer very short. 5.15. In the year 1992, what is the difference between the Rent(as % of GDP) in Least developed countries and Rent(as % of GDP) in Uruguay?
Give a very brief answer. 5.25. In the year 1992, what is the difference between the Rent(as % of GDP) of Albania and Rent(as % of GDP) of Comoros?
Offer a very short reply. 8.18. In the year 1992, what is the difference between the Rent(as % of GDP) in Albania and Rent(as % of GDP) in Uruguay?
Provide a succinct answer. 8.27. In the year 1992, what is the difference between the Rent(as % of GDP) in Comoros and Rent(as % of GDP) in Uruguay?
Your answer should be very brief. 0.1. In the year 1993, what is the difference between the Rent(as % of GDP) in Least developed countries and Rent(as % of GDP) in Albania?
Offer a very short reply. 4.81. In the year 1993, what is the difference between the Rent(as % of GDP) in Least developed countries and Rent(as % of GDP) in Comoros?
Your response must be concise. 4.47. In the year 1993, what is the difference between the Rent(as % of GDP) of Least developed countries and Rent(as % of GDP) of Uruguay?
Ensure brevity in your answer.  4.56. In the year 1993, what is the difference between the Rent(as % of GDP) of Albania and Rent(as % of GDP) of Comoros?
Your answer should be compact. -0.34. In the year 1993, what is the difference between the Rent(as % of GDP) in Albania and Rent(as % of GDP) in Uruguay?
Offer a very short reply. -0.25. In the year 1993, what is the difference between the Rent(as % of GDP) of Comoros and Rent(as % of GDP) of Uruguay?
Ensure brevity in your answer.  0.09. In the year 1994, what is the difference between the Rent(as % of GDP) of Least developed countries and Rent(as % of GDP) of Albania?
Make the answer very short. 7.31. In the year 1994, what is the difference between the Rent(as % of GDP) of Least developed countries and Rent(as % of GDP) of Comoros?
Keep it short and to the point. 5.96. In the year 1994, what is the difference between the Rent(as % of GDP) of Least developed countries and Rent(as % of GDP) of Uruguay?
Ensure brevity in your answer.  7.09. In the year 1994, what is the difference between the Rent(as % of GDP) of Albania and Rent(as % of GDP) of Comoros?
Provide a succinct answer. -1.35. In the year 1994, what is the difference between the Rent(as % of GDP) of Albania and Rent(as % of GDP) of Uruguay?
Offer a terse response. -0.23. In the year 1994, what is the difference between the Rent(as % of GDP) in Comoros and Rent(as % of GDP) in Uruguay?
Offer a terse response. 1.13. In the year 1995, what is the difference between the Rent(as % of GDP) of Least developed countries and Rent(as % of GDP) of Albania?
Make the answer very short. 9.68. In the year 1995, what is the difference between the Rent(as % of GDP) in Least developed countries and Rent(as % of GDP) in Comoros?
Keep it short and to the point. 7.09. In the year 1995, what is the difference between the Rent(as % of GDP) in Least developed countries and Rent(as % of GDP) in Uruguay?
Give a very brief answer. 9.18. In the year 1995, what is the difference between the Rent(as % of GDP) of Albania and Rent(as % of GDP) of Comoros?
Your answer should be very brief. -2.59. In the year 1995, what is the difference between the Rent(as % of GDP) of Albania and Rent(as % of GDP) of Uruguay?
Keep it short and to the point. -0.5. In the year 1995, what is the difference between the Rent(as % of GDP) of Comoros and Rent(as % of GDP) of Uruguay?
Your answer should be very brief. 2.1. In the year 1996, what is the difference between the Rent(as % of GDP) in Least developed countries and Rent(as % of GDP) in Albania?
Keep it short and to the point. 8.43. In the year 1996, what is the difference between the Rent(as % of GDP) of Least developed countries and Rent(as % of GDP) of Comoros?
Your answer should be very brief. 5.73. In the year 1996, what is the difference between the Rent(as % of GDP) in Least developed countries and Rent(as % of GDP) in Uruguay?
Your answer should be compact. 7.88. In the year 1996, what is the difference between the Rent(as % of GDP) in Albania and Rent(as % of GDP) in Comoros?
Your answer should be very brief. -2.7. In the year 1996, what is the difference between the Rent(as % of GDP) in Albania and Rent(as % of GDP) in Uruguay?
Keep it short and to the point. -0.55. In the year 1996, what is the difference between the Rent(as % of GDP) of Comoros and Rent(as % of GDP) of Uruguay?
Offer a very short reply. 2.16. In the year 1997, what is the difference between the Rent(as % of GDP) in Least developed countries and Rent(as % of GDP) in Albania?
Make the answer very short. 7.36. In the year 1997, what is the difference between the Rent(as % of GDP) of Least developed countries and Rent(as % of GDP) of Comoros?
Your response must be concise. 4.69. In the year 1997, what is the difference between the Rent(as % of GDP) in Least developed countries and Rent(as % of GDP) in Uruguay?
Give a very brief answer. 6.97. In the year 1997, what is the difference between the Rent(as % of GDP) of Albania and Rent(as % of GDP) of Comoros?
Provide a short and direct response. -2.67. In the year 1997, what is the difference between the Rent(as % of GDP) of Albania and Rent(as % of GDP) of Uruguay?
Offer a terse response. -0.39. In the year 1997, what is the difference between the Rent(as % of GDP) in Comoros and Rent(as % of GDP) in Uruguay?
Your response must be concise. 2.28. In the year 1998, what is the difference between the Rent(as % of GDP) of Least developed countries and Rent(as % of GDP) of Albania?
Offer a very short reply. 7.88. In the year 1998, what is the difference between the Rent(as % of GDP) of Least developed countries and Rent(as % of GDP) of Comoros?
Ensure brevity in your answer.  4.75. In the year 1998, what is the difference between the Rent(as % of GDP) in Least developed countries and Rent(as % of GDP) in Uruguay?
Keep it short and to the point. 7.15. In the year 1998, what is the difference between the Rent(as % of GDP) in Albania and Rent(as % of GDP) in Comoros?
Provide a succinct answer. -3.13. In the year 1998, what is the difference between the Rent(as % of GDP) of Albania and Rent(as % of GDP) of Uruguay?
Your answer should be compact. -0.73. In the year 1998, what is the difference between the Rent(as % of GDP) of Comoros and Rent(as % of GDP) of Uruguay?
Give a very brief answer. 2.4. In the year 1999, what is the difference between the Rent(as % of GDP) of Least developed countries and Rent(as % of GDP) of Albania?
Your response must be concise. 5.25. In the year 1999, what is the difference between the Rent(as % of GDP) in Least developed countries and Rent(as % of GDP) in Comoros?
Provide a short and direct response. 3.19. In the year 1999, what is the difference between the Rent(as % of GDP) of Least developed countries and Rent(as % of GDP) of Uruguay?
Provide a short and direct response. 4.73. In the year 1999, what is the difference between the Rent(as % of GDP) in Albania and Rent(as % of GDP) in Comoros?
Make the answer very short. -2.06. In the year 1999, what is the difference between the Rent(as % of GDP) of Albania and Rent(as % of GDP) of Uruguay?
Ensure brevity in your answer.  -0.53. In the year 1999, what is the difference between the Rent(as % of GDP) of Comoros and Rent(as % of GDP) of Uruguay?
Your answer should be very brief. 1.54. What is the ratio of the Rent(as % of GDP) of Least developed countries in 1992 to that in 1993?
Provide a short and direct response. 1.16. What is the ratio of the Rent(as % of GDP) of Albania in 1992 to that in 1993?
Offer a terse response. 13.29. What is the ratio of the Rent(as % of GDP) of Comoros in 1992 to that in 1993?
Provide a short and direct response. 1.2. What is the ratio of the Rent(as % of GDP) in Uruguay in 1992 to that in 1993?
Ensure brevity in your answer.  1.21. What is the ratio of the Rent(as % of GDP) of Least developed countries in 1992 to that in 1994?
Your response must be concise. 0.82. What is the ratio of the Rent(as % of GDP) of Albania in 1992 to that in 1994?
Provide a short and direct response. 17.8. What is the ratio of the Rent(as % of GDP) in Comoros in 1992 to that in 1994?
Keep it short and to the point. 0.67. What is the ratio of the Rent(as % of GDP) in Uruguay in 1992 to that in 1994?
Your response must be concise. 1.54. What is the ratio of the Rent(as % of GDP) of Least developed countries in 1992 to that in 1995?
Give a very brief answer. 0.64. What is the ratio of the Rent(as % of GDP) of Albania in 1992 to that in 1995?
Make the answer very short. 28.84. What is the ratio of the Rent(as % of GDP) in Comoros in 1992 to that in 1995?
Make the answer very short. 0.43. What is the ratio of the Rent(as % of GDP) of Uruguay in 1992 to that in 1995?
Give a very brief answer. 1.41. What is the ratio of the Rent(as % of GDP) in Least developed countries in 1992 to that in 1996?
Your answer should be very brief. 0.74. What is the ratio of the Rent(as % of GDP) of Albania in 1992 to that in 1996?
Your response must be concise. 34.6. What is the ratio of the Rent(as % of GDP) in Comoros in 1992 to that in 1996?
Your response must be concise. 0.42. What is the ratio of the Rent(as % of GDP) in Uruguay in 1992 to that in 1996?
Your response must be concise. 1.42. What is the ratio of the Rent(as % of GDP) in Least developed countries in 1992 to that in 1997?
Provide a short and direct response. 0.83. What is the ratio of the Rent(as % of GDP) in Albania in 1992 to that in 1997?
Your answer should be very brief. 26.87. What is the ratio of the Rent(as % of GDP) of Comoros in 1992 to that in 1997?
Your answer should be compact. 0.42. What is the ratio of the Rent(as % of GDP) in Uruguay in 1992 to that in 1997?
Make the answer very short. 1.56. What is the ratio of the Rent(as % of GDP) of Least developed countries in 1992 to that in 1998?
Offer a very short reply. 0.81. What is the ratio of the Rent(as % of GDP) in Albania in 1992 to that in 1998?
Ensure brevity in your answer.  459.25. What is the ratio of the Rent(as % of GDP) in Comoros in 1992 to that in 1998?
Make the answer very short. 0.4. What is the ratio of the Rent(as % of GDP) of Uruguay in 1992 to that in 1998?
Keep it short and to the point. 1.55. What is the ratio of the Rent(as % of GDP) in Least developed countries in 1992 to that in 1999?
Offer a very short reply. 1.19. What is the ratio of the Rent(as % of GDP) of Albania in 1992 to that in 1999?
Ensure brevity in your answer.  77.21. What is the ratio of the Rent(as % of GDP) in Comoros in 1992 to that in 1999?
Keep it short and to the point. 0.58. What is the ratio of the Rent(as % of GDP) of Uruguay in 1992 to that in 1999?
Ensure brevity in your answer.  1.79. What is the ratio of the Rent(as % of GDP) of Least developed countries in 1993 to that in 1994?
Offer a very short reply. 0.7. What is the ratio of the Rent(as % of GDP) of Albania in 1993 to that in 1994?
Provide a short and direct response. 1.34. What is the ratio of the Rent(as % of GDP) in Comoros in 1993 to that in 1994?
Make the answer very short. 0.56. What is the ratio of the Rent(as % of GDP) in Uruguay in 1993 to that in 1994?
Give a very brief answer. 1.27. What is the ratio of the Rent(as % of GDP) in Least developed countries in 1993 to that in 1995?
Ensure brevity in your answer.  0.55. What is the ratio of the Rent(as % of GDP) of Albania in 1993 to that in 1995?
Your answer should be compact. 2.17. What is the ratio of the Rent(as % of GDP) in Comoros in 1993 to that in 1995?
Your response must be concise. 0.36. What is the ratio of the Rent(as % of GDP) of Uruguay in 1993 to that in 1995?
Your answer should be compact. 1.17. What is the ratio of the Rent(as % of GDP) of Least developed countries in 1993 to that in 1996?
Your answer should be compact. 0.63. What is the ratio of the Rent(as % of GDP) of Albania in 1993 to that in 1996?
Make the answer very short. 2.6. What is the ratio of the Rent(as % of GDP) of Comoros in 1993 to that in 1996?
Provide a succinct answer. 0.35. What is the ratio of the Rent(as % of GDP) of Uruguay in 1993 to that in 1996?
Your answer should be compact. 1.17. What is the ratio of the Rent(as % of GDP) in Least developed countries in 1993 to that in 1997?
Your answer should be very brief. 0.72. What is the ratio of the Rent(as % of GDP) of Albania in 1993 to that in 1997?
Ensure brevity in your answer.  2.02. What is the ratio of the Rent(as % of GDP) of Comoros in 1993 to that in 1997?
Your response must be concise. 0.35. What is the ratio of the Rent(as % of GDP) of Uruguay in 1993 to that in 1997?
Offer a terse response. 1.29. What is the ratio of the Rent(as % of GDP) of Least developed countries in 1993 to that in 1998?
Offer a terse response. 0.7. What is the ratio of the Rent(as % of GDP) of Albania in 1993 to that in 1998?
Your answer should be very brief. 34.57. What is the ratio of the Rent(as % of GDP) of Comoros in 1993 to that in 1998?
Provide a succinct answer. 0.33. What is the ratio of the Rent(as % of GDP) of Uruguay in 1993 to that in 1998?
Your response must be concise. 1.28. What is the ratio of the Rent(as % of GDP) of Least developed countries in 1993 to that in 1999?
Offer a terse response. 1.03. What is the ratio of the Rent(as % of GDP) of Albania in 1993 to that in 1999?
Offer a very short reply. 5.81. What is the ratio of the Rent(as % of GDP) of Comoros in 1993 to that in 1999?
Your answer should be compact. 0.48. What is the ratio of the Rent(as % of GDP) in Uruguay in 1993 to that in 1999?
Provide a succinct answer. 1.49. What is the ratio of the Rent(as % of GDP) in Least developed countries in 1994 to that in 1995?
Make the answer very short. 0.78. What is the ratio of the Rent(as % of GDP) of Albania in 1994 to that in 1995?
Offer a terse response. 1.62. What is the ratio of the Rent(as % of GDP) of Comoros in 1994 to that in 1995?
Your response must be concise. 0.65. What is the ratio of the Rent(as % of GDP) in Uruguay in 1994 to that in 1995?
Provide a short and direct response. 0.92. What is the ratio of the Rent(as % of GDP) in Least developed countries in 1994 to that in 1996?
Your answer should be compact. 0.9. What is the ratio of the Rent(as % of GDP) of Albania in 1994 to that in 1996?
Ensure brevity in your answer.  1.94. What is the ratio of the Rent(as % of GDP) in Comoros in 1994 to that in 1996?
Your response must be concise. 0.63. What is the ratio of the Rent(as % of GDP) of Uruguay in 1994 to that in 1996?
Your answer should be compact. 0.92. What is the ratio of the Rent(as % of GDP) in Least developed countries in 1994 to that in 1997?
Keep it short and to the point. 1.02. What is the ratio of the Rent(as % of GDP) of Albania in 1994 to that in 1997?
Give a very brief answer. 1.51. What is the ratio of the Rent(as % of GDP) in Comoros in 1994 to that in 1997?
Keep it short and to the point. 0.62. What is the ratio of the Rent(as % of GDP) in Uruguay in 1994 to that in 1997?
Offer a very short reply. 1.01. What is the ratio of the Rent(as % of GDP) of Least developed countries in 1994 to that in 1998?
Your answer should be compact. 0.99. What is the ratio of the Rent(as % of GDP) in Albania in 1994 to that in 1998?
Offer a terse response. 25.8. What is the ratio of the Rent(as % of GDP) of Comoros in 1994 to that in 1998?
Ensure brevity in your answer.  0.6. What is the ratio of the Rent(as % of GDP) in Least developed countries in 1994 to that in 1999?
Your response must be concise. 1.46. What is the ratio of the Rent(as % of GDP) in Albania in 1994 to that in 1999?
Your response must be concise. 4.34. What is the ratio of the Rent(as % of GDP) in Comoros in 1994 to that in 1999?
Offer a terse response. 0.86. What is the ratio of the Rent(as % of GDP) in Uruguay in 1994 to that in 1999?
Offer a very short reply. 1.17. What is the ratio of the Rent(as % of GDP) of Least developed countries in 1995 to that in 1996?
Keep it short and to the point. 1.15. What is the ratio of the Rent(as % of GDP) of Albania in 1995 to that in 1996?
Offer a terse response. 1.2. What is the ratio of the Rent(as % of GDP) in Comoros in 1995 to that in 1996?
Ensure brevity in your answer.  0.98. What is the ratio of the Rent(as % of GDP) of Uruguay in 1995 to that in 1996?
Offer a very short reply. 1.01. What is the ratio of the Rent(as % of GDP) of Least developed countries in 1995 to that in 1997?
Make the answer very short. 1.3. What is the ratio of the Rent(as % of GDP) of Albania in 1995 to that in 1997?
Make the answer very short. 0.93. What is the ratio of the Rent(as % of GDP) of Comoros in 1995 to that in 1997?
Make the answer very short. 0.97. What is the ratio of the Rent(as % of GDP) in Uruguay in 1995 to that in 1997?
Make the answer very short. 1.11. What is the ratio of the Rent(as % of GDP) of Least developed countries in 1995 to that in 1998?
Your response must be concise. 1.27. What is the ratio of the Rent(as % of GDP) of Albania in 1995 to that in 1998?
Give a very brief answer. 15.93. What is the ratio of the Rent(as % of GDP) in Comoros in 1995 to that in 1998?
Ensure brevity in your answer.  0.93. What is the ratio of the Rent(as % of GDP) of Uruguay in 1995 to that in 1998?
Offer a very short reply. 1.1. What is the ratio of the Rent(as % of GDP) of Least developed countries in 1995 to that in 1999?
Make the answer very short. 1.86. What is the ratio of the Rent(as % of GDP) of Albania in 1995 to that in 1999?
Provide a succinct answer. 2.68. What is the ratio of the Rent(as % of GDP) in Comoros in 1995 to that in 1999?
Make the answer very short. 1.34. What is the ratio of the Rent(as % of GDP) of Uruguay in 1995 to that in 1999?
Your response must be concise. 1.27. What is the ratio of the Rent(as % of GDP) of Least developed countries in 1996 to that in 1997?
Offer a very short reply. 1.13. What is the ratio of the Rent(as % of GDP) in Albania in 1996 to that in 1997?
Provide a succinct answer. 0.78. What is the ratio of the Rent(as % of GDP) of Comoros in 1996 to that in 1997?
Ensure brevity in your answer.  0.98. What is the ratio of the Rent(as % of GDP) of Uruguay in 1996 to that in 1997?
Offer a very short reply. 1.1. What is the ratio of the Rent(as % of GDP) of Least developed countries in 1996 to that in 1998?
Keep it short and to the point. 1.1. What is the ratio of the Rent(as % of GDP) of Albania in 1996 to that in 1998?
Provide a succinct answer. 13.27. What is the ratio of the Rent(as % of GDP) of Comoros in 1996 to that in 1998?
Your response must be concise. 0.95. What is the ratio of the Rent(as % of GDP) of Uruguay in 1996 to that in 1998?
Keep it short and to the point. 1.09. What is the ratio of the Rent(as % of GDP) of Least developed countries in 1996 to that in 1999?
Your response must be concise. 1.62. What is the ratio of the Rent(as % of GDP) in Albania in 1996 to that in 1999?
Provide a short and direct response. 2.23. What is the ratio of the Rent(as % of GDP) in Comoros in 1996 to that in 1999?
Your response must be concise. 1.36. What is the ratio of the Rent(as % of GDP) of Uruguay in 1996 to that in 1999?
Ensure brevity in your answer.  1.26. What is the ratio of the Rent(as % of GDP) of Least developed countries in 1997 to that in 1998?
Make the answer very short. 0.98. What is the ratio of the Rent(as % of GDP) in Albania in 1997 to that in 1998?
Your response must be concise. 17.09. What is the ratio of the Rent(as % of GDP) of Comoros in 1997 to that in 1998?
Offer a very short reply. 0.96. What is the ratio of the Rent(as % of GDP) of Uruguay in 1997 to that in 1998?
Your answer should be compact. 0.99. What is the ratio of the Rent(as % of GDP) in Least developed countries in 1997 to that in 1999?
Your answer should be very brief. 1.43. What is the ratio of the Rent(as % of GDP) of Albania in 1997 to that in 1999?
Your response must be concise. 2.87. What is the ratio of the Rent(as % of GDP) of Comoros in 1997 to that in 1999?
Give a very brief answer. 1.38. What is the ratio of the Rent(as % of GDP) in Uruguay in 1997 to that in 1999?
Your response must be concise. 1.15. What is the ratio of the Rent(as % of GDP) of Least developed countries in 1998 to that in 1999?
Your response must be concise. 1.47. What is the ratio of the Rent(as % of GDP) in Albania in 1998 to that in 1999?
Offer a terse response. 0.17. What is the ratio of the Rent(as % of GDP) in Comoros in 1998 to that in 1999?
Your response must be concise. 1.44. What is the ratio of the Rent(as % of GDP) of Uruguay in 1998 to that in 1999?
Provide a short and direct response. 1.16. What is the difference between the highest and the second highest Rent(as % of GDP) of Least developed countries?
Provide a succinct answer. 1.31. What is the difference between the highest and the second highest Rent(as % of GDP) of Albania?
Give a very brief answer. 8.73. What is the difference between the highest and the second highest Rent(as % of GDP) of Comoros?
Make the answer very short. 0.12. What is the difference between the highest and the second highest Rent(as % of GDP) of Uruguay?
Your answer should be very brief. 0.2. What is the difference between the highest and the lowest Rent(as % of GDP) of Least developed countries?
Give a very brief answer. 4.63. What is the difference between the highest and the lowest Rent(as % of GDP) of Albania?
Offer a very short reply. 9.42. What is the difference between the highest and the lowest Rent(as % of GDP) in Comoros?
Provide a short and direct response. 2.1. What is the difference between the highest and the lowest Rent(as % of GDP) in Uruguay?
Provide a succinct answer. 0.51. 